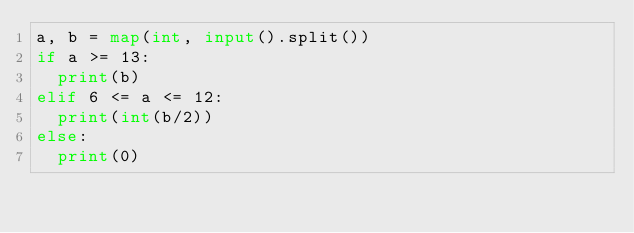<code> <loc_0><loc_0><loc_500><loc_500><_Python_>a, b = map(int, input().split())
if a >= 13:
  print(b)
elif 6 <= a <= 12:
  print(int(b/2))
else:
  print(0)</code> 